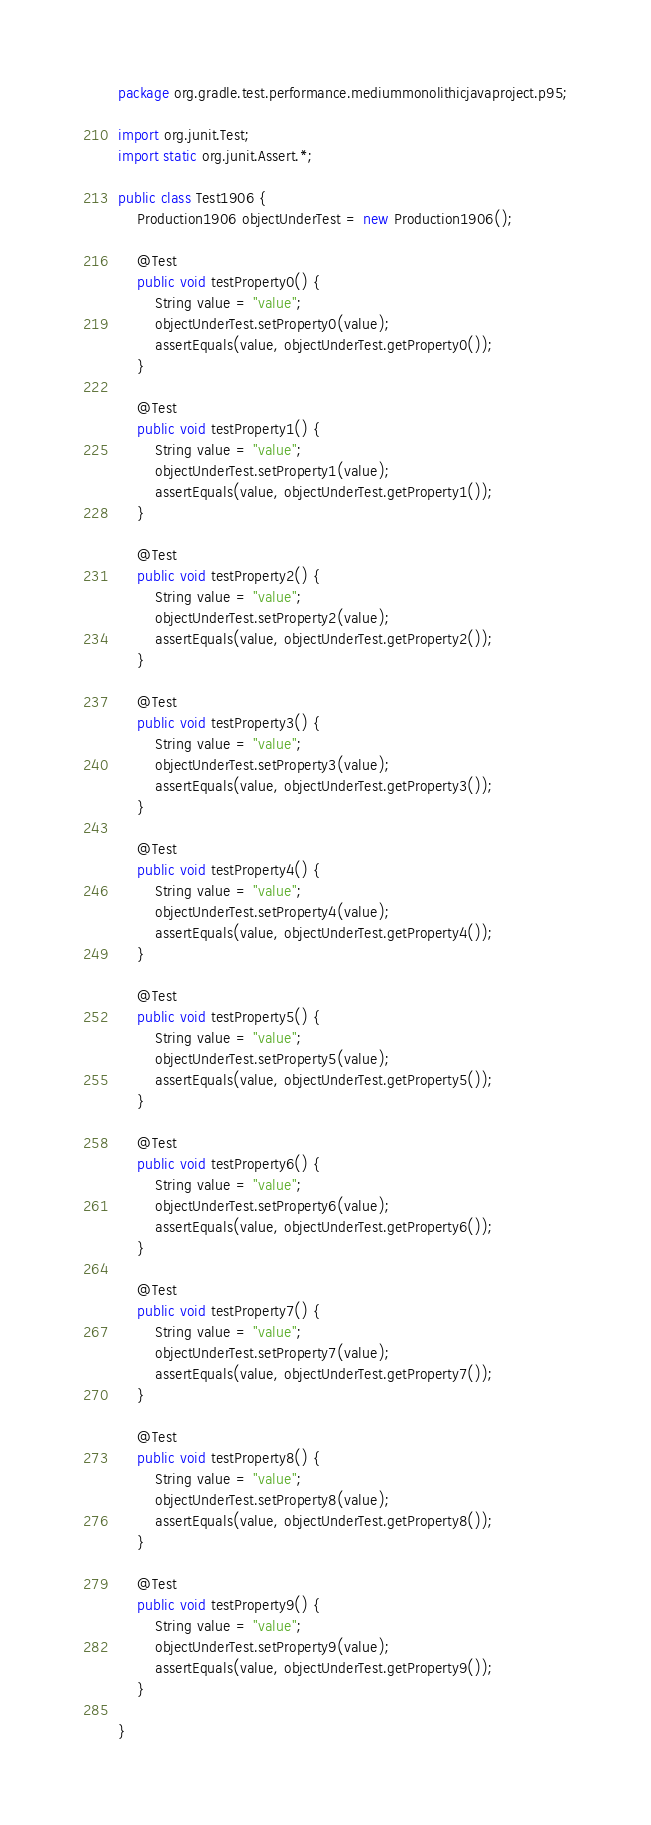Convert code to text. <code><loc_0><loc_0><loc_500><loc_500><_Java_>package org.gradle.test.performance.mediummonolithicjavaproject.p95;

import org.junit.Test;
import static org.junit.Assert.*;

public class Test1906 {  
    Production1906 objectUnderTest = new Production1906();     

    @Test
    public void testProperty0() {
        String value = "value";
        objectUnderTest.setProperty0(value);
        assertEquals(value, objectUnderTest.getProperty0());
    }

    @Test
    public void testProperty1() {
        String value = "value";
        objectUnderTest.setProperty1(value);
        assertEquals(value, objectUnderTest.getProperty1());
    }

    @Test
    public void testProperty2() {
        String value = "value";
        objectUnderTest.setProperty2(value);
        assertEquals(value, objectUnderTest.getProperty2());
    }

    @Test
    public void testProperty3() {
        String value = "value";
        objectUnderTest.setProperty3(value);
        assertEquals(value, objectUnderTest.getProperty3());
    }

    @Test
    public void testProperty4() {
        String value = "value";
        objectUnderTest.setProperty4(value);
        assertEquals(value, objectUnderTest.getProperty4());
    }

    @Test
    public void testProperty5() {
        String value = "value";
        objectUnderTest.setProperty5(value);
        assertEquals(value, objectUnderTest.getProperty5());
    }

    @Test
    public void testProperty6() {
        String value = "value";
        objectUnderTest.setProperty6(value);
        assertEquals(value, objectUnderTest.getProperty6());
    }

    @Test
    public void testProperty7() {
        String value = "value";
        objectUnderTest.setProperty7(value);
        assertEquals(value, objectUnderTest.getProperty7());
    }

    @Test
    public void testProperty8() {
        String value = "value";
        objectUnderTest.setProperty8(value);
        assertEquals(value, objectUnderTest.getProperty8());
    }

    @Test
    public void testProperty9() {
        String value = "value";
        objectUnderTest.setProperty9(value);
        assertEquals(value, objectUnderTest.getProperty9());
    }

}</code> 